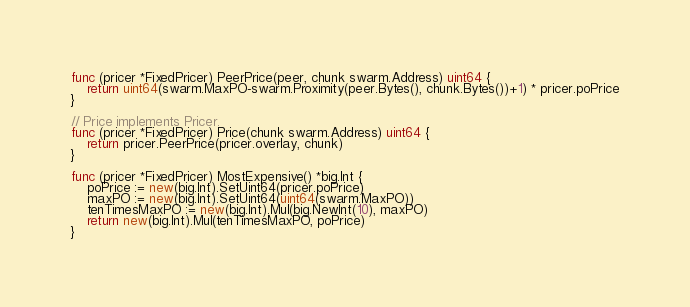Convert code to text. <code><loc_0><loc_0><loc_500><loc_500><_Go_>func (pricer *FixedPricer) PeerPrice(peer, chunk swarm.Address) uint64 {
	return uint64(swarm.MaxPO-swarm.Proximity(peer.Bytes(), chunk.Bytes())+1) * pricer.poPrice
}

// Price implements Pricer.
func (pricer *FixedPricer) Price(chunk swarm.Address) uint64 {
	return pricer.PeerPrice(pricer.overlay, chunk)
}

func (pricer *FixedPricer) MostExpensive() *big.Int {
	poPrice := new(big.Int).SetUint64(pricer.poPrice)
	maxPO := new(big.Int).SetUint64(uint64(swarm.MaxPO))
	tenTimesMaxPO := new(big.Int).Mul(big.NewInt(10), maxPO)
	return new(big.Int).Mul(tenTimesMaxPO, poPrice)
}
</code> 